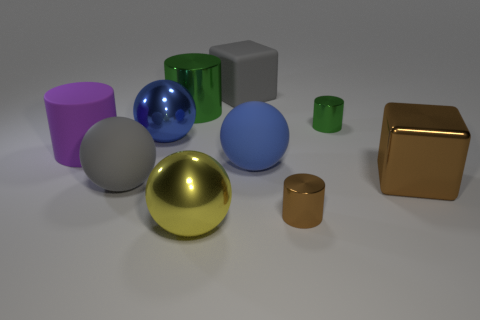Subtract 1 spheres. How many spheres are left? 3 Subtract all spheres. How many objects are left? 6 Add 2 large purple objects. How many large purple objects exist? 3 Subtract 1 gray balls. How many objects are left? 9 Subtract all large gray rubber cubes. Subtract all small metal things. How many objects are left? 7 Add 3 blue metallic balls. How many blue metallic balls are left? 4 